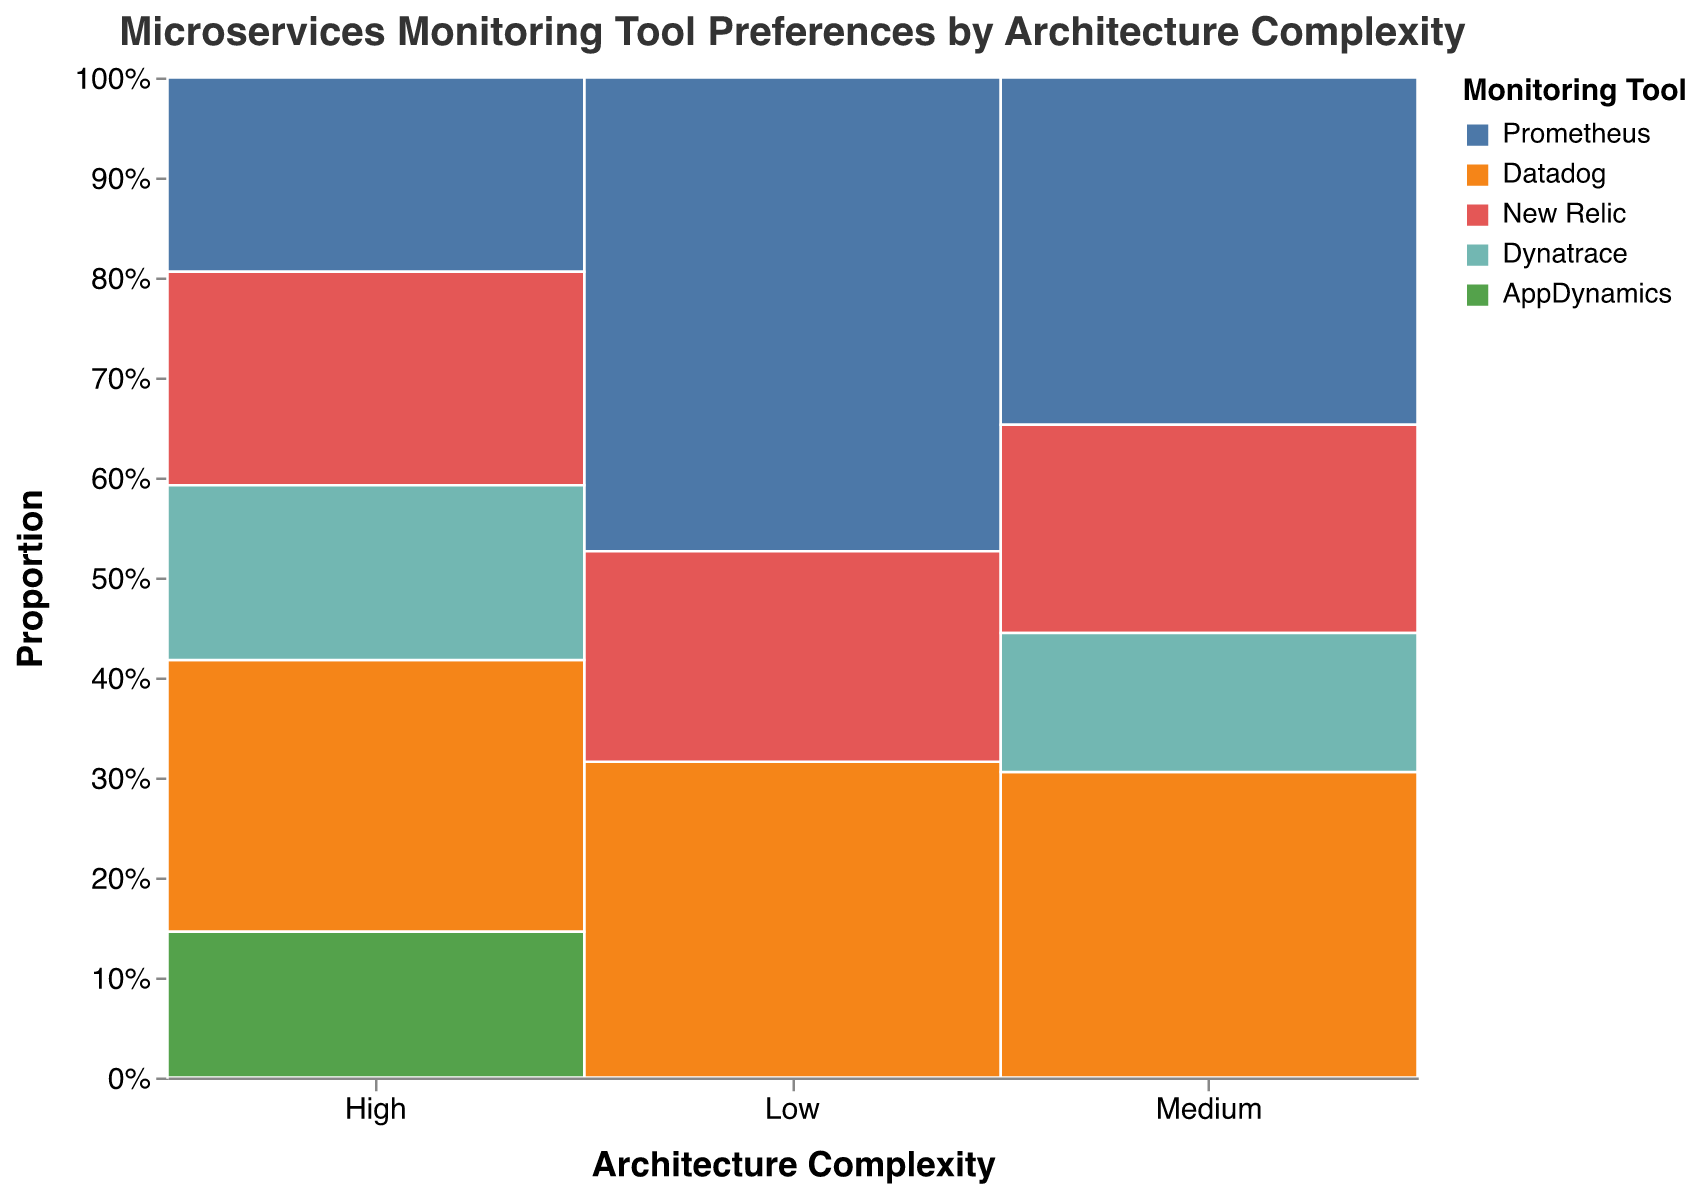Which monitoring tool has the highest preference count for high architecture complexity? Look at the figure for the "High" architecture complexity section and identify the monitoring tool with the highest segment. The tallest bar belongs to "Datadog".
Answer: Datadog What is the total preference count for medium architecture complexity? Sum the preference counts for all monitoring tools under the "Medium" architecture complexity section: Prometheus (25) + Datadog (22) + New Relic (15) + Dynatrace (10).
Answer: 72 Which monitoring tool has a higher preference count in high architecture complexity compared to low architecture complexity? Compare the preference counts of each monitoring tool between "High" and "Low" architecture complexities. Datadog (28 vs. 12) and New Relic (22 vs. 8) have higher counts in "High" compared to "Low".
Answer: Datadog, New Relic What is the average preference count of monitoring tools in low architecture complexity? Sum the preference counts for all tools in the "Low" category and divide by the number of tools: (18 + 12 + 8) / 3.
Answer: 12.67 How does the preference for Prometheus change as architecture complexity increases? Observe the heights of the Prometheus bars across "Low", "Medium", and "High" complexities. The preference count is 18 in "Low", 25 in "Medium", and 20 in "High", showing an increase and then a decrease.
Answer: Increase then decrease What percentage of the total preferences for high architecture complexity does AppDynamics represent? Calculate the proportion for AppDynamics in the "High" category: (15 / (20 + 28 + 22 + 18 + 15)) * 100%.
Answer: 13.3% Which architecture complexity has the most diverse range of preferred monitoring tools? Identify the architecture complexity section with the most different monitoring tools. "High" complexity has five different tools.
Answer: High Is the preference for New Relic higher in medium or high architecture complexity? Compare the heights and counts in "Medium" vs. "High" for New Relic: 15 in "Medium" and 22 in "High".
Answer: High What is the difference between the preference counts of Dynatrace in medium and high architecture complexity? Subtract the preference count of Dynatrace in "Medium" from the count in "High": 18 - 10.
Answer: 8 